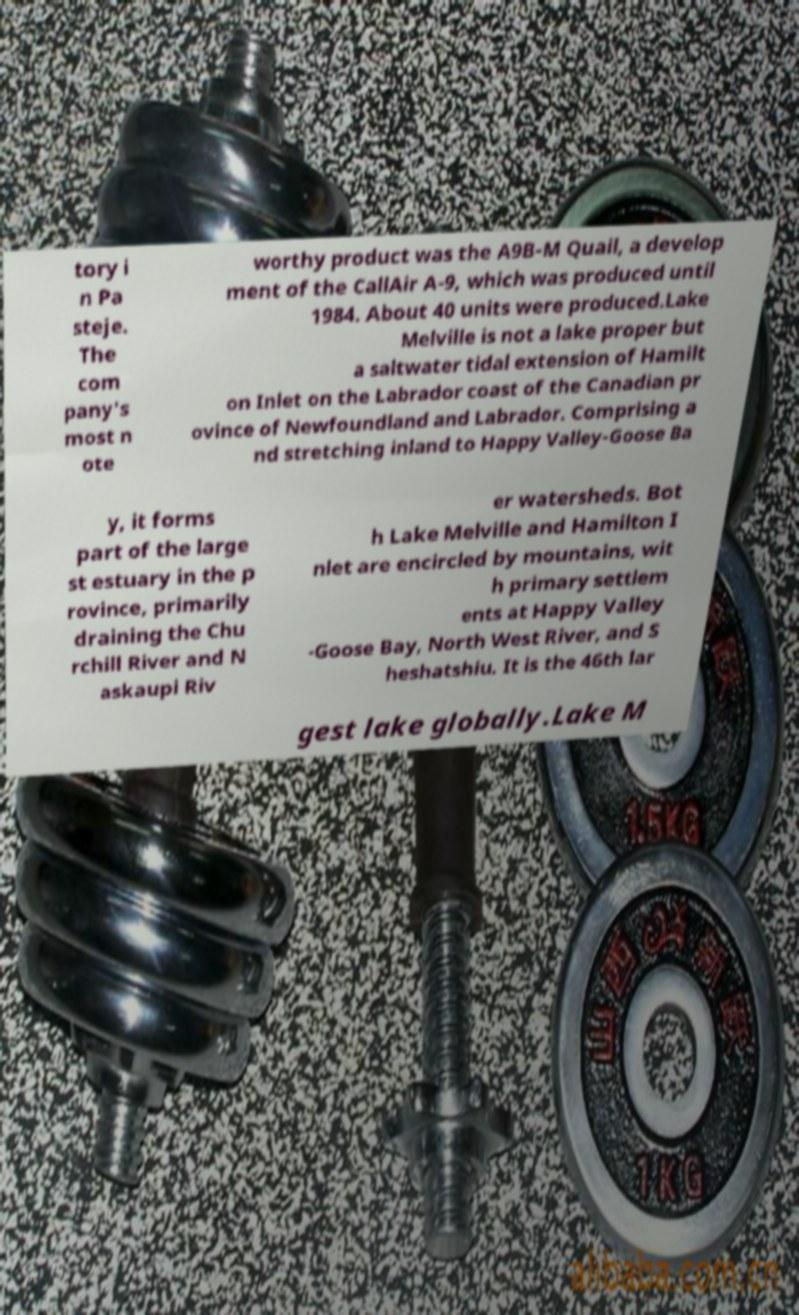Please read and relay the text visible in this image. What does it say? tory i n Pa steje. The com pany's most n ote worthy product was the A9B-M Quail, a develop ment of the CallAir A-9, which was produced until 1984. About 40 units were produced.Lake Melville is not a lake proper but a saltwater tidal extension of Hamilt on Inlet on the Labrador coast of the Canadian pr ovince of Newfoundland and Labrador. Comprising a nd stretching inland to Happy Valley-Goose Ba y, it forms part of the large st estuary in the p rovince, primarily draining the Chu rchill River and N askaupi Riv er watersheds. Bot h Lake Melville and Hamilton I nlet are encircled by mountains, wit h primary settlem ents at Happy Valley -Goose Bay, North West River, and S heshatshiu. It is the 46th lar gest lake globally.Lake M 